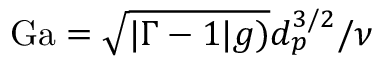<formula> <loc_0><loc_0><loc_500><loc_500>G a = \sqrt { | \Gamma - 1 | g ) } d _ { p } ^ { 3 / 2 } / \nu</formula> 